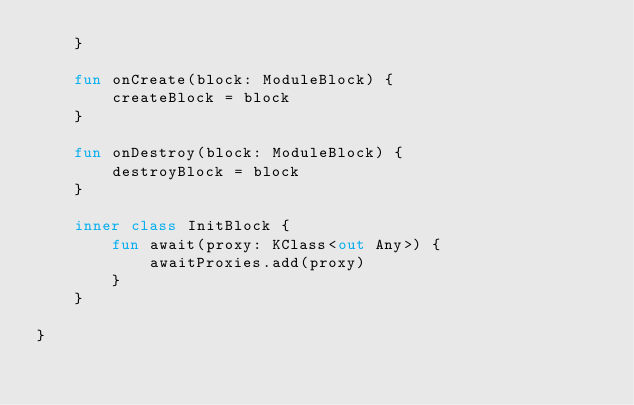<code> <loc_0><loc_0><loc_500><loc_500><_Kotlin_>    }

    fun onCreate(block: ModuleBlock) {
        createBlock = block
    }

    fun onDestroy(block: ModuleBlock) {
        destroyBlock = block
    }

    inner class InitBlock {
        fun await(proxy: KClass<out Any>) {
            awaitProxies.add(proxy)
        }
    }

}
</code> 